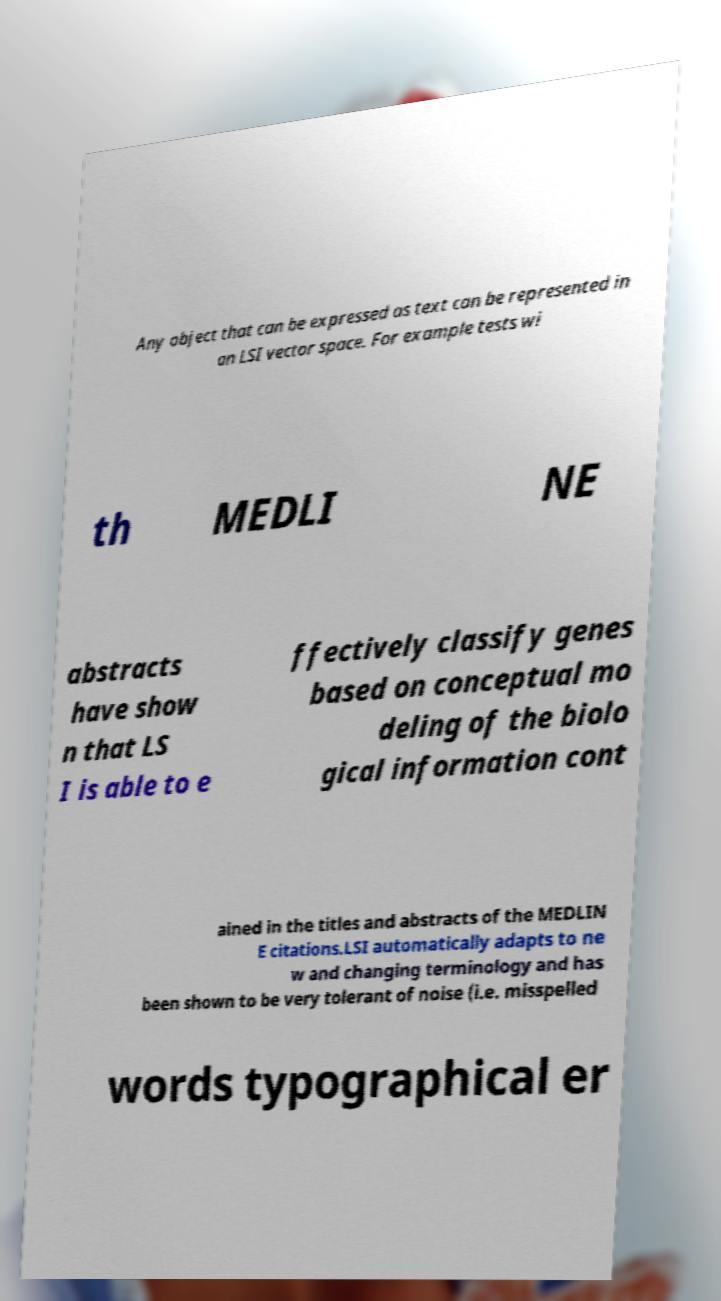For documentation purposes, I need the text within this image transcribed. Could you provide that? Any object that can be expressed as text can be represented in an LSI vector space. For example tests wi th MEDLI NE abstracts have show n that LS I is able to e ffectively classify genes based on conceptual mo deling of the biolo gical information cont ained in the titles and abstracts of the MEDLIN E citations.LSI automatically adapts to ne w and changing terminology and has been shown to be very tolerant of noise (i.e. misspelled words typographical er 